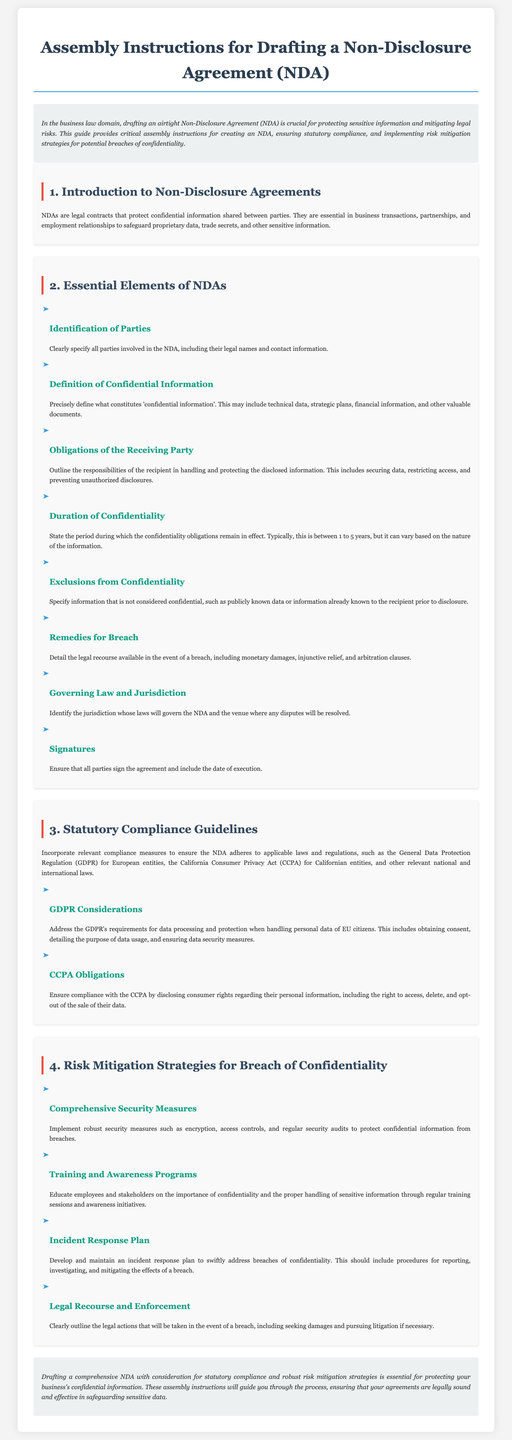What is the main purpose of an NDA? The introduction states that the primary goal is to protect sensitive information and mitigate legal risks.
Answer: Protecting sensitive information What is the duration of confidentiality mentioned? The document states that the confidentiality obligations typically last between 1 to 5 years, but can vary based on the information.
Answer: 1 to 5 years What should the obligations of the receiving party include? The section on obligations specifies responsibilities such as securing data, restricting access, and preventing unauthorized disclosures.
Answer: Securing data Which laws are referenced for statutory compliance? The section on compliance guidelines mentions GDPR and CCPA as relevant laws for statutory compliance.
Answer: GDPR and CCPA What is one type of remedy for breach mentioned in the document? The section on remedies for breach indicates that legal recourse can include monetary damages.
Answer: Monetary damages What should an incident response plan include? The risk mitigation strategies highlight that the incident response plan should address procedures for reporting, investigating, and mitigating a breach.
Answer: Procedures for reporting Who signs the NDA? The section on signatures clearly states that all parties must sign the agreement.
Answer: All parties What measure is suggested for securing confidential information? The document indicates the implementation of robust security measures, such as encryption and access controls, as a suggested measure.
Answer: Robust security measures What education method is recommended for confidentiality awareness? The section on training suggests regular training sessions and awareness initiatives for educating employees.
Answer: Regular training sessions 